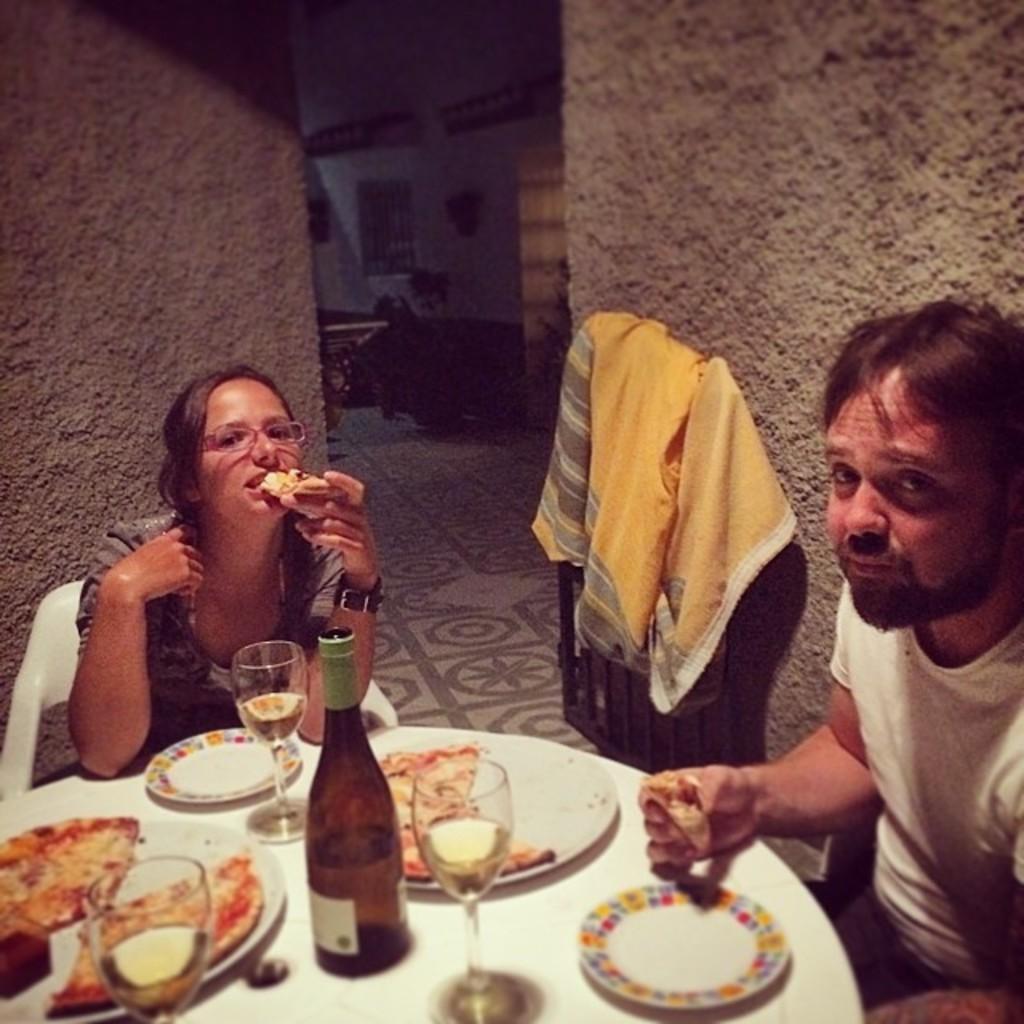In one or two sentences, can you explain what this image depicts? In this picture we can see a woman sitting on a chair and eating pizza and giving a pose to the camera. On the right side there is a man sitting and giving a pose to the camera. Behind we can see the yellow cloth and wall. In the front bottom side there is a dining table with pizza, wine bottle and glasses. 